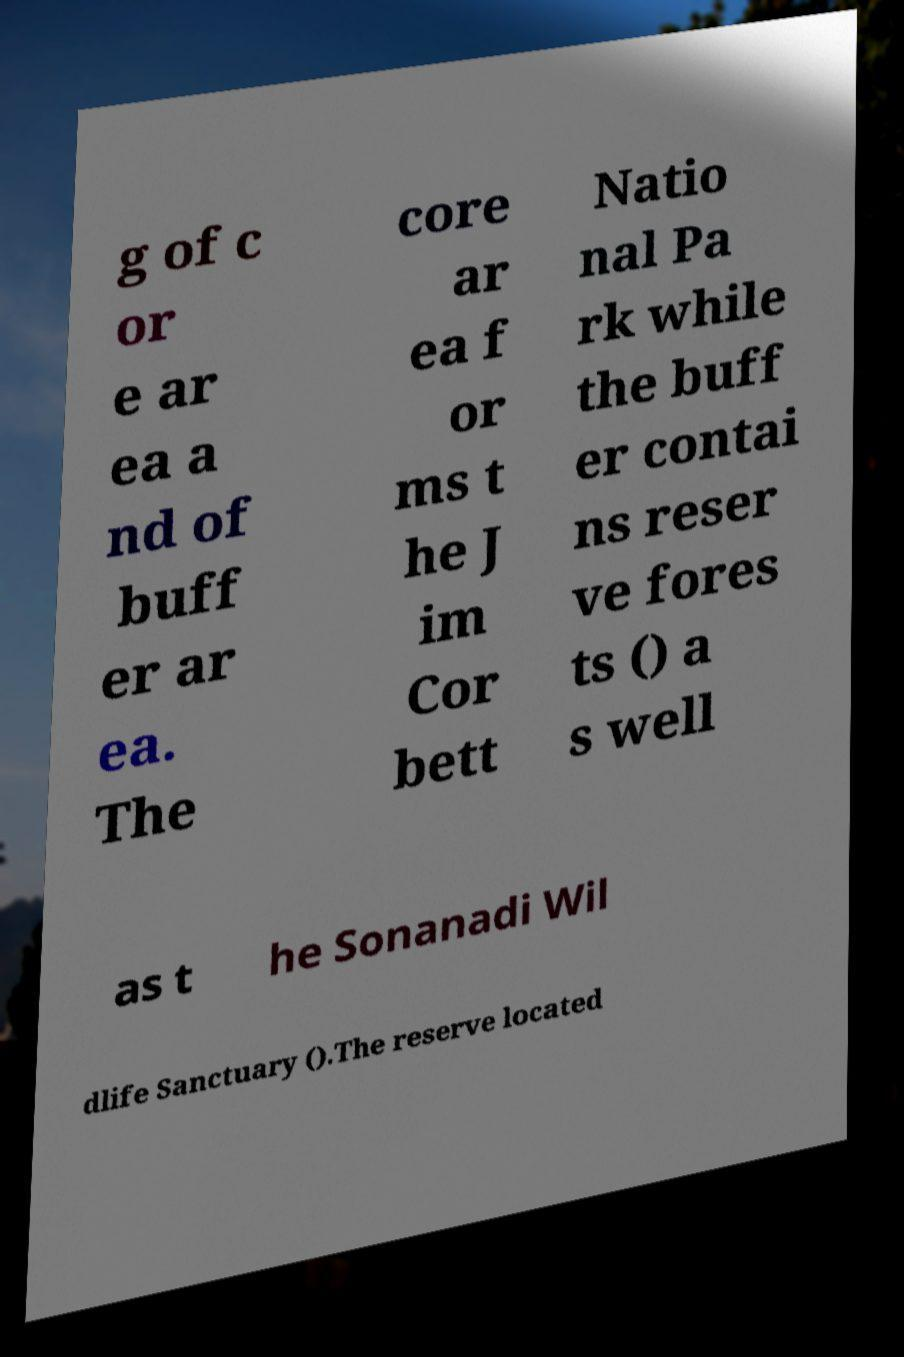Can you accurately transcribe the text from the provided image for me? g of c or e ar ea a nd of buff er ar ea. The core ar ea f or ms t he J im Cor bett Natio nal Pa rk while the buff er contai ns reser ve fores ts () a s well as t he Sonanadi Wil dlife Sanctuary ().The reserve located 